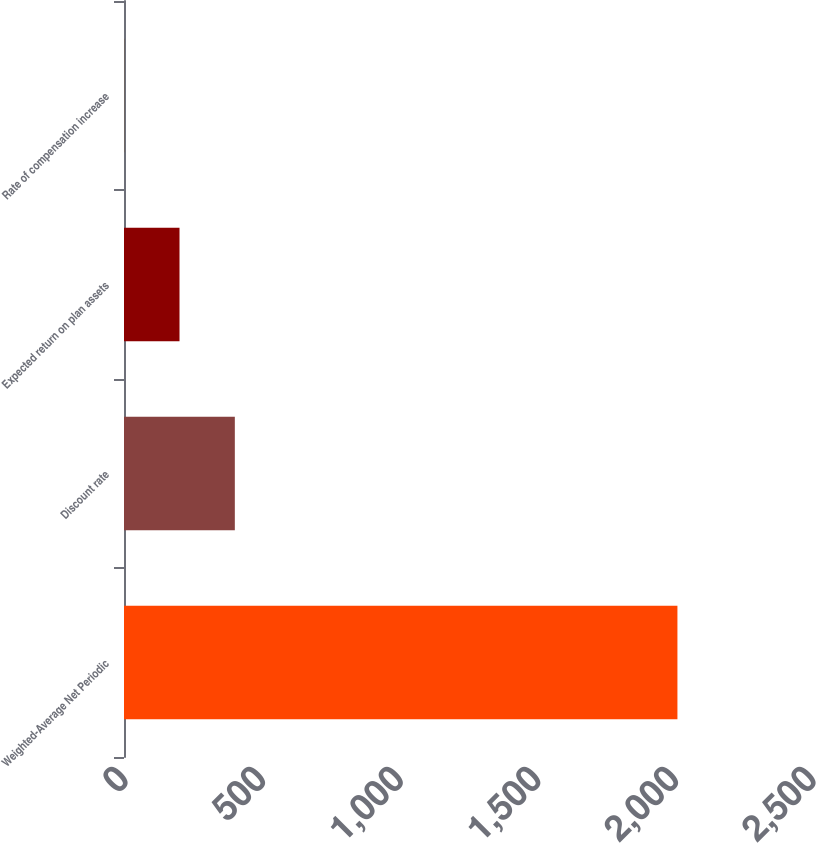<chart> <loc_0><loc_0><loc_500><loc_500><bar_chart><fcel>Weighted-Average Net Periodic<fcel>Discount rate<fcel>Expected return on plan assets<fcel>Rate of compensation increase<nl><fcel>2011<fcel>402.74<fcel>201.71<fcel>0.68<nl></chart> 